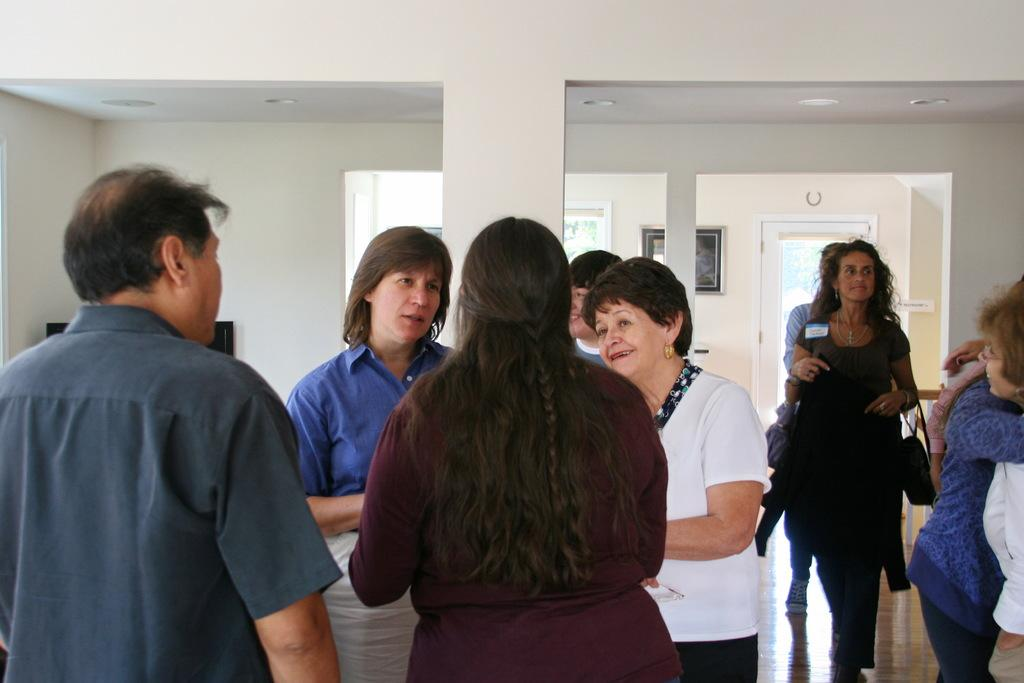What are the people in the image doing? The people in the image are standing. What is the woman in the image doing? The woman in the image is walking and carrying a work bag. What architectural features can be seen in the image? There are pillars in the image. What can be seen on the wall in the background? There are frames on a wall in the background. What is located in the background of the image? There is a door in the background. Can you tell me how many eggs are on the woman's head in the image? There are no eggs present on the woman's head in the image. What type of baseball is being played in the background of the image? There is no baseball being played in the image; it does not feature any baseball-related elements. 